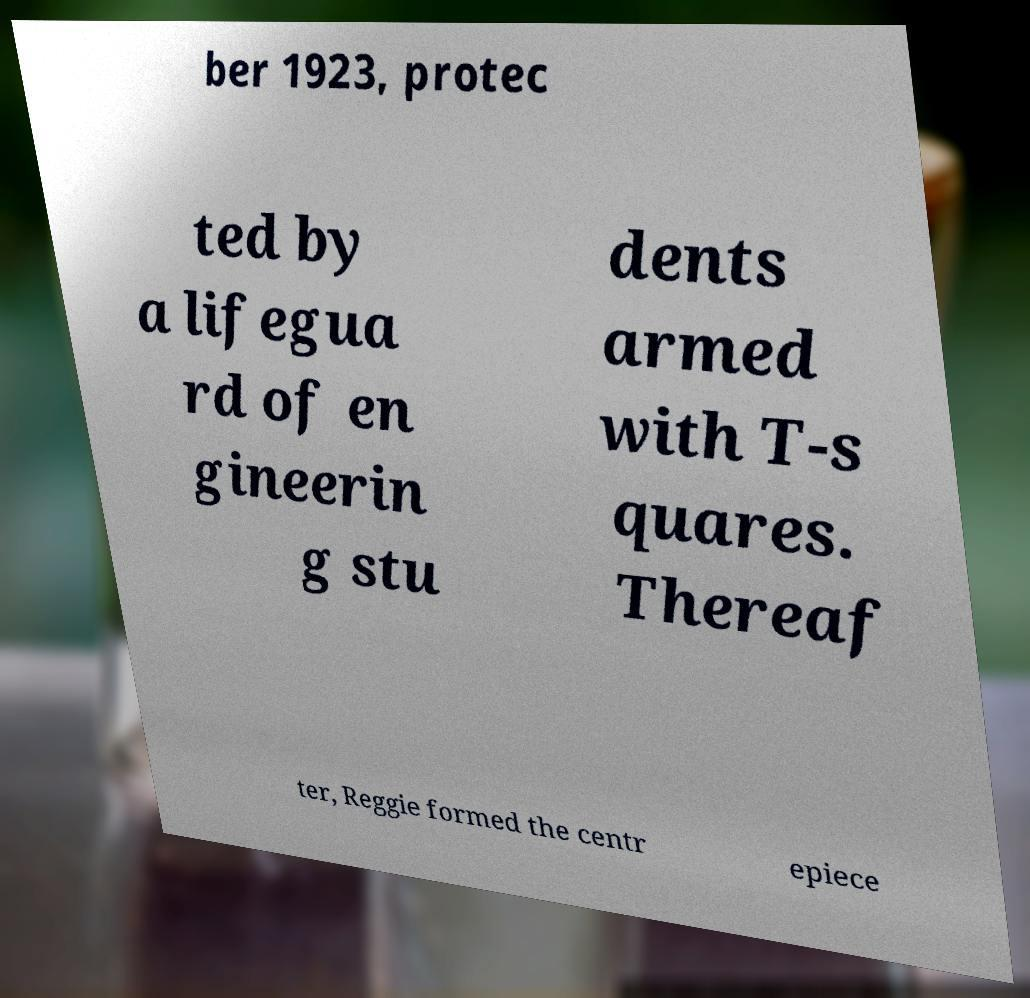I need the written content from this picture converted into text. Can you do that? ber 1923, protec ted by a lifegua rd of en gineerin g stu dents armed with T-s quares. Thereaf ter, Reggie formed the centr epiece 